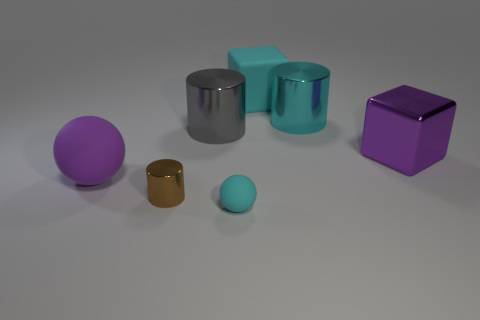Subtract all large metal cylinders. How many cylinders are left? 1 Add 1 metal objects. How many objects exist? 8 Subtract all cyan balls. How many balls are left? 1 Subtract 1 blocks. How many blocks are left? 1 Subtract all blocks. How many objects are left? 5 Add 4 large shiny blocks. How many large shiny blocks are left? 5 Add 7 rubber cylinders. How many rubber cylinders exist? 7 Subtract 0 green cylinders. How many objects are left? 7 Subtract all green balls. Subtract all brown cylinders. How many balls are left? 2 Subtract all large purple shiny objects. Subtract all small metal things. How many objects are left? 5 